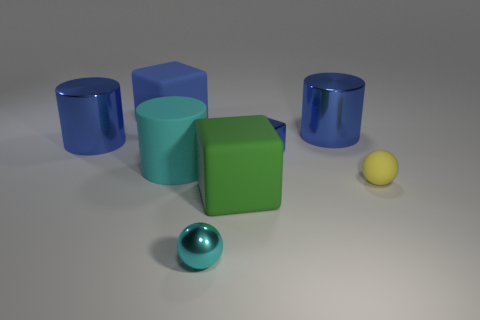How many blue cylinders must be subtracted to get 1 blue cylinders? 1 Subtract all green cubes. How many blue cylinders are left? 2 Subtract all big green rubber cubes. How many cubes are left? 2 Add 1 matte balls. How many objects exist? 9 Add 8 large blocks. How many large blocks exist? 10 Subtract 0 gray balls. How many objects are left? 8 Subtract all cylinders. How many objects are left? 5 Subtract all gray cubes. Subtract all purple spheres. How many cubes are left? 3 Subtract all large blue rubber objects. Subtract all tiny yellow matte things. How many objects are left? 6 Add 5 cyan rubber cylinders. How many cyan rubber cylinders are left? 6 